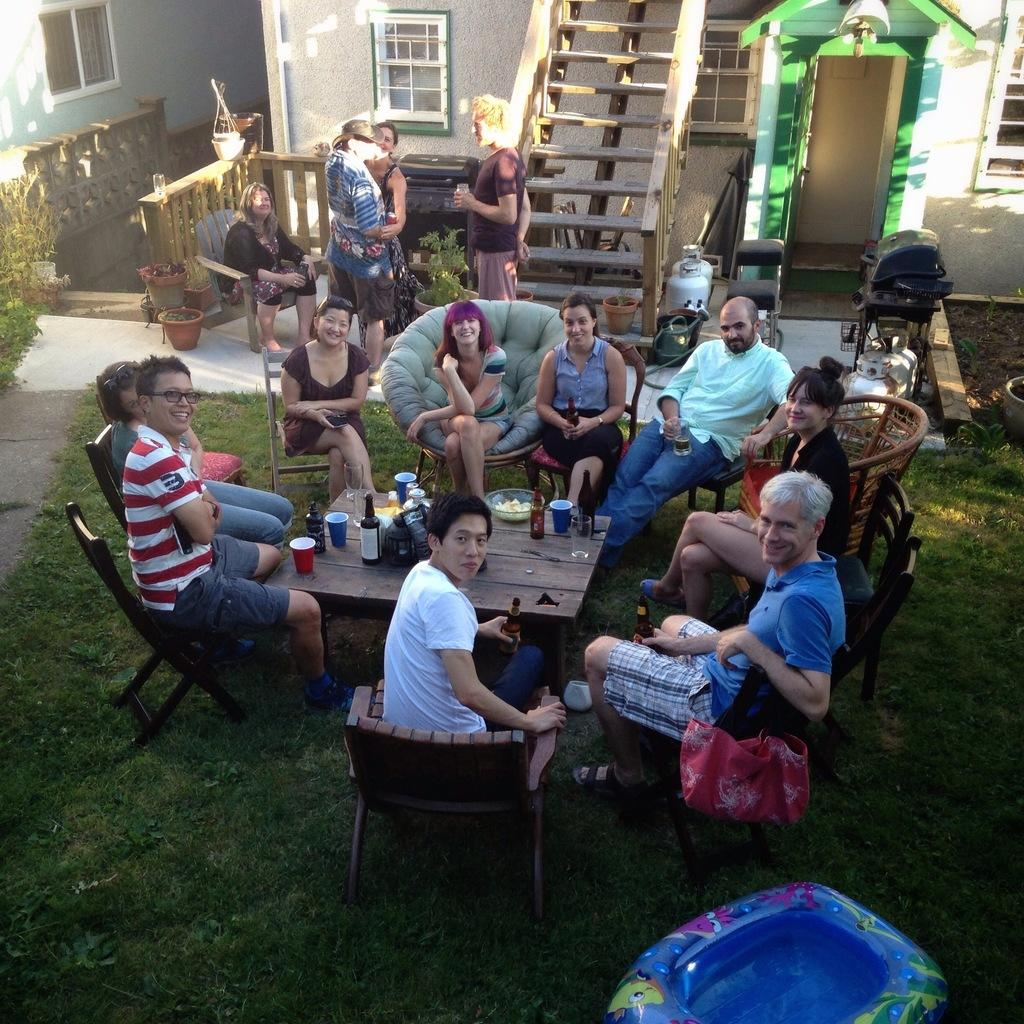Who or what is present in the image? There are people in the image. What are the people doing in the image? The people are sitting on chairs. What is the main piece of furniture in the image? There is a table in the image. What can be found on the table in the image? There are wine glasses and glasses on the table. What type of oil is being used to lubricate the conversation in the image? There is no oil present in the image, nor is there any indication of a conversation being lubricated. 